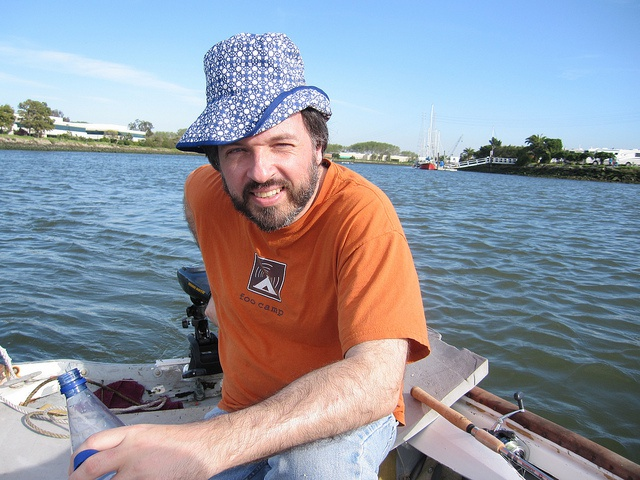Describe the objects in this image and their specific colors. I can see people in lightblue, lightgray, brown, and lightpink tones, boat in lightblue, darkgray, lightgray, gray, and black tones, bottle in lightblue, darkgray, gray, and lightgray tones, boat in lightblue, maroon, salmon, gray, and brown tones, and boat in lightblue, lightgray, darkgray, beige, and gray tones in this image. 